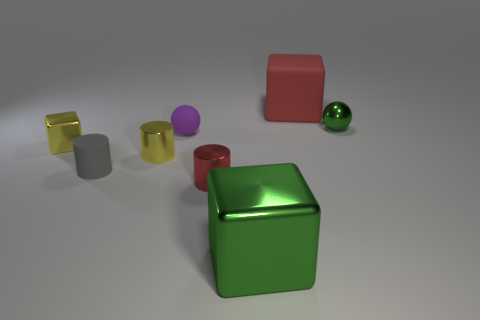How many other things are the same color as the big rubber object?
Provide a succinct answer. 1. There is a large block to the right of the shiny block in front of the yellow cylinder; what number of green objects are to the right of it?
Your answer should be compact. 1. There is a red thing that is behind the tiny matte cylinder; is its size the same as the ball to the right of the red block?
Your response must be concise. No. There is a small yellow thing that is the same shape as the small red thing; what material is it?
Ensure brevity in your answer.  Metal. How many big objects are cyan metal spheres or purple rubber balls?
Your response must be concise. 0. What is the material of the gray cylinder?
Keep it short and to the point. Rubber. There is a small thing that is right of the purple rubber thing and left of the tiny green metal ball; what is it made of?
Ensure brevity in your answer.  Metal. There is a tiny metal ball; does it have the same color as the large thing in front of the tiny green metallic ball?
Provide a short and direct response. Yes. What material is the red cylinder that is the same size as the gray thing?
Your answer should be very brief. Metal. Are there any purple objects made of the same material as the tiny red object?
Your answer should be compact. No. 